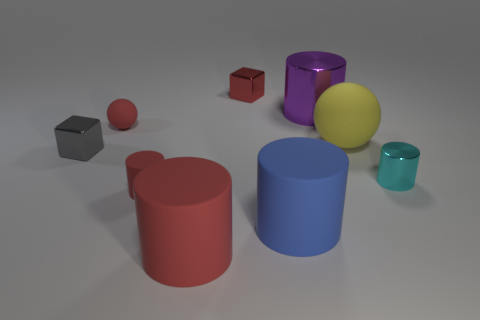Is the number of metallic cubes that are in front of the big purple object greater than the number of tiny red objects?
Give a very brief answer. No. Are there any small rubber spheres of the same color as the big shiny cylinder?
Provide a short and direct response. No. There is a sphere that is the same size as the cyan shiny cylinder; what is its color?
Provide a short and direct response. Red. How many large cylinders are in front of the big rubber object behind the big blue matte cylinder?
Make the answer very short. 2. What number of objects are small red matte cylinders that are to the left of the small red metallic cube or small green blocks?
Provide a succinct answer. 1. How many large blue things have the same material as the tiny red ball?
Give a very brief answer. 1. What is the shape of the big rubber thing that is the same color as the tiny rubber cylinder?
Your answer should be very brief. Cylinder. Are there an equal number of objects to the left of the big rubber sphere and tiny balls?
Provide a succinct answer. No. What size is the red rubber object behind the tiny gray metal thing?
Keep it short and to the point. Small. How many big things are cyan rubber balls or gray metal things?
Provide a succinct answer. 0. 